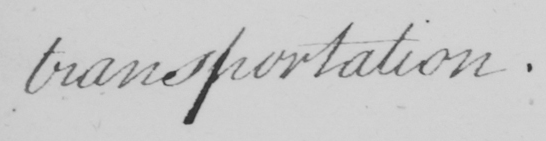What is written in this line of handwriting? transportation . 